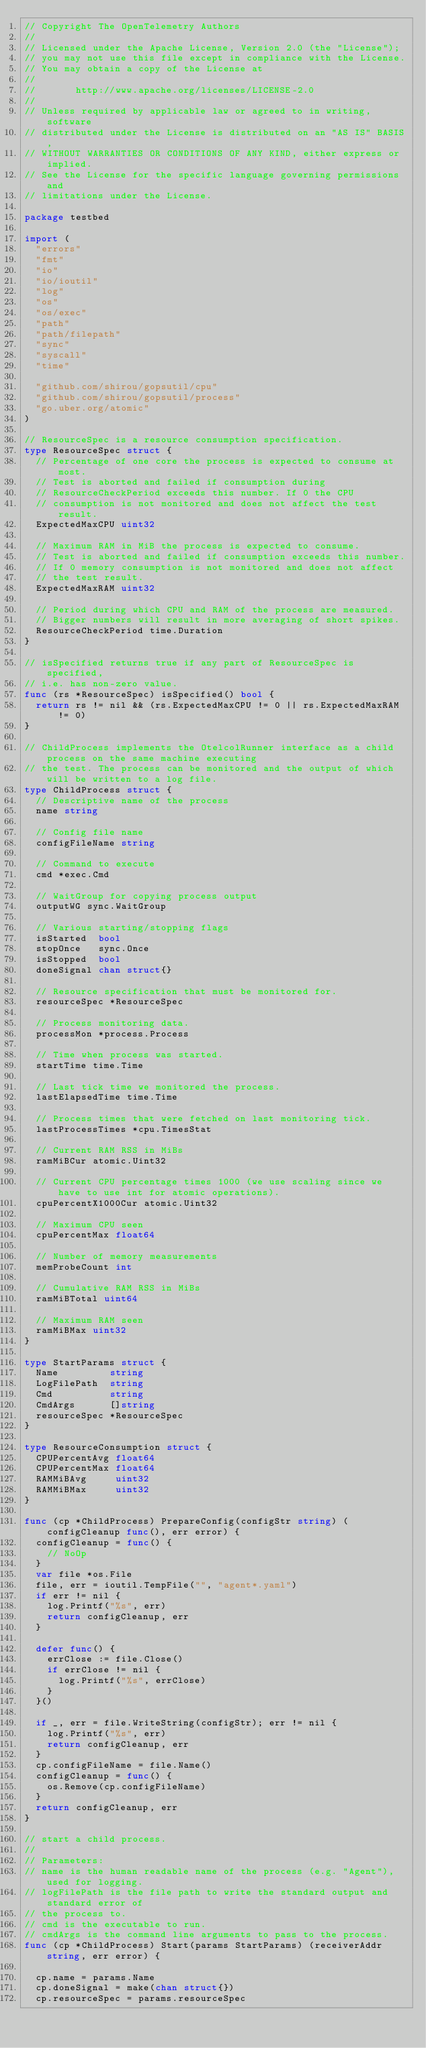<code> <loc_0><loc_0><loc_500><loc_500><_Go_>// Copyright The OpenTelemetry Authors
//
// Licensed under the Apache License, Version 2.0 (the "License");
// you may not use this file except in compliance with the License.
// You may obtain a copy of the License at
//
//       http://www.apache.org/licenses/LICENSE-2.0
//
// Unless required by applicable law or agreed to in writing, software
// distributed under the License is distributed on an "AS IS" BASIS,
// WITHOUT WARRANTIES OR CONDITIONS OF ANY KIND, either express or implied.
// See the License for the specific language governing permissions and
// limitations under the License.

package testbed

import (
	"errors"
	"fmt"
	"io"
	"io/ioutil"
	"log"
	"os"
	"os/exec"
	"path"
	"path/filepath"
	"sync"
	"syscall"
	"time"

	"github.com/shirou/gopsutil/cpu"
	"github.com/shirou/gopsutil/process"
	"go.uber.org/atomic"
)

// ResourceSpec is a resource consumption specification.
type ResourceSpec struct {
	// Percentage of one core the process is expected to consume at most.
	// Test is aborted and failed if consumption during
	// ResourceCheckPeriod exceeds this number. If 0 the CPU
	// consumption is not monitored and does not affect the test result.
	ExpectedMaxCPU uint32

	// Maximum RAM in MiB the process is expected to consume.
	// Test is aborted and failed if consumption exceeds this number.
	// If 0 memory consumption is not monitored and does not affect
	// the test result.
	ExpectedMaxRAM uint32

	// Period during which CPU and RAM of the process are measured.
	// Bigger numbers will result in more averaging of short spikes.
	ResourceCheckPeriod time.Duration
}

// isSpecified returns true if any part of ResourceSpec is specified,
// i.e. has non-zero value.
func (rs *ResourceSpec) isSpecified() bool {
	return rs != nil && (rs.ExpectedMaxCPU != 0 || rs.ExpectedMaxRAM != 0)
}

// ChildProcess implements the OtelcolRunner interface as a child process on the same machine executing
// the test. The process can be monitored and the output of which will be written to a log file.
type ChildProcess struct {
	// Descriptive name of the process
	name string

	// Config file name
	configFileName string

	// Command to execute
	cmd *exec.Cmd

	// WaitGroup for copying process output
	outputWG sync.WaitGroup

	// Various starting/stopping flags
	isStarted  bool
	stopOnce   sync.Once
	isStopped  bool
	doneSignal chan struct{}

	// Resource specification that must be monitored for.
	resourceSpec *ResourceSpec

	// Process monitoring data.
	processMon *process.Process

	// Time when process was started.
	startTime time.Time

	// Last tick time we monitored the process.
	lastElapsedTime time.Time

	// Process times that were fetched on last monitoring tick.
	lastProcessTimes *cpu.TimesStat

	// Current RAM RSS in MiBs
	ramMiBCur atomic.Uint32

	// Current CPU percentage times 1000 (we use scaling since we have to use int for atomic operations).
	cpuPercentX1000Cur atomic.Uint32

	// Maximum CPU seen
	cpuPercentMax float64

	// Number of memory measurements
	memProbeCount int

	// Cumulative RAM RSS in MiBs
	ramMiBTotal uint64

	// Maximum RAM seen
	ramMiBMax uint32
}

type StartParams struct {
	Name         string
	LogFilePath  string
	Cmd          string
	CmdArgs      []string
	resourceSpec *ResourceSpec
}

type ResourceConsumption struct {
	CPUPercentAvg float64
	CPUPercentMax float64
	RAMMiBAvg     uint32
	RAMMiBMax     uint32
}

func (cp *ChildProcess) PrepareConfig(configStr string) (configCleanup func(), err error) {
	configCleanup = func() {
		// NoOp
	}
	var file *os.File
	file, err = ioutil.TempFile("", "agent*.yaml")
	if err != nil {
		log.Printf("%s", err)
		return configCleanup, err
	}

	defer func() {
		errClose := file.Close()
		if errClose != nil {
			log.Printf("%s", errClose)
		}
	}()

	if _, err = file.WriteString(configStr); err != nil {
		log.Printf("%s", err)
		return configCleanup, err
	}
	cp.configFileName = file.Name()
	configCleanup = func() {
		os.Remove(cp.configFileName)
	}
	return configCleanup, err
}

// start a child process.
//
// Parameters:
// name is the human readable name of the process (e.g. "Agent"), used for logging.
// logFilePath is the file path to write the standard output and standard error of
// the process to.
// cmd is the executable to run.
// cmdArgs is the command line arguments to pass to the process.
func (cp *ChildProcess) Start(params StartParams) (receiverAddr string, err error) {

	cp.name = params.Name
	cp.doneSignal = make(chan struct{})
	cp.resourceSpec = params.resourceSpec
</code> 